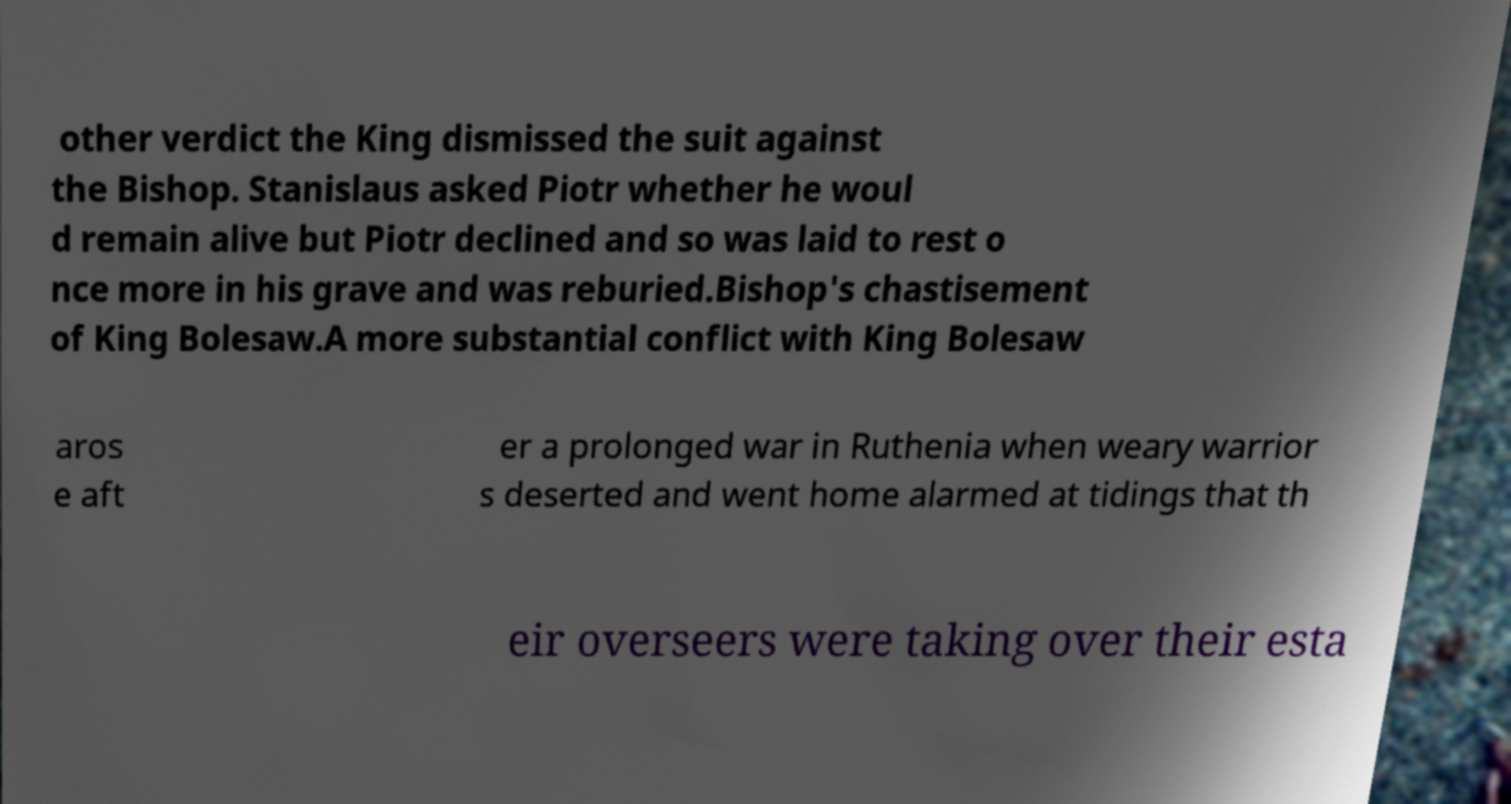Could you extract and type out the text from this image? other verdict the King dismissed the suit against the Bishop. Stanislaus asked Piotr whether he woul d remain alive but Piotr declined and so was laid to rest o nce more in his grave and was reburied.Bishop's chastisement of King Bolesaw.A more substantial conflict with King Bolesaw aros e aft er a prolonged war in Ruthenia when weary warrior s deserted and went home alarmed at tidings that th eir overseers were taking over their esta 